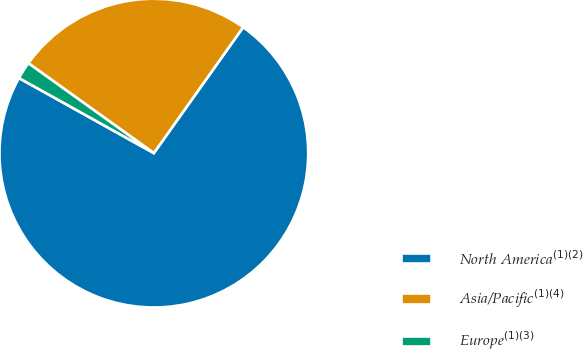<chart> <loc_0><loc_0><loc_500><loc_500><pie_chart><fcel>North America$^{(1)(2)}$<fcel>Asia/Pacific$^{(1)(4)}$<fcel>Europe$^{(1)(3)}$<nl><fcel>73.27%<fcel>24.93%<fcel>1.81%<nl></chart> 